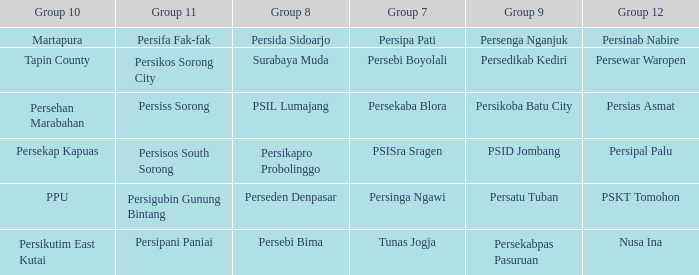Who played in group 8 when Persinab Nabire played in Group 12? Persida Sidoarjo. 